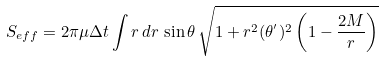Convert formula to latex. <formula><loc_0><loc_0><loc_500><loc_500>S _ { e f f } = 2 \pi \mu \Delta t \int r \, d r \, \sin \theta \, \sqrt { 1 + r ^ { 2 } ( \theta ^ { ^ { \prime } } ) ^ { 2 } \left ( 1 - \frac { 2 M } { r } \right ) }</formula> 